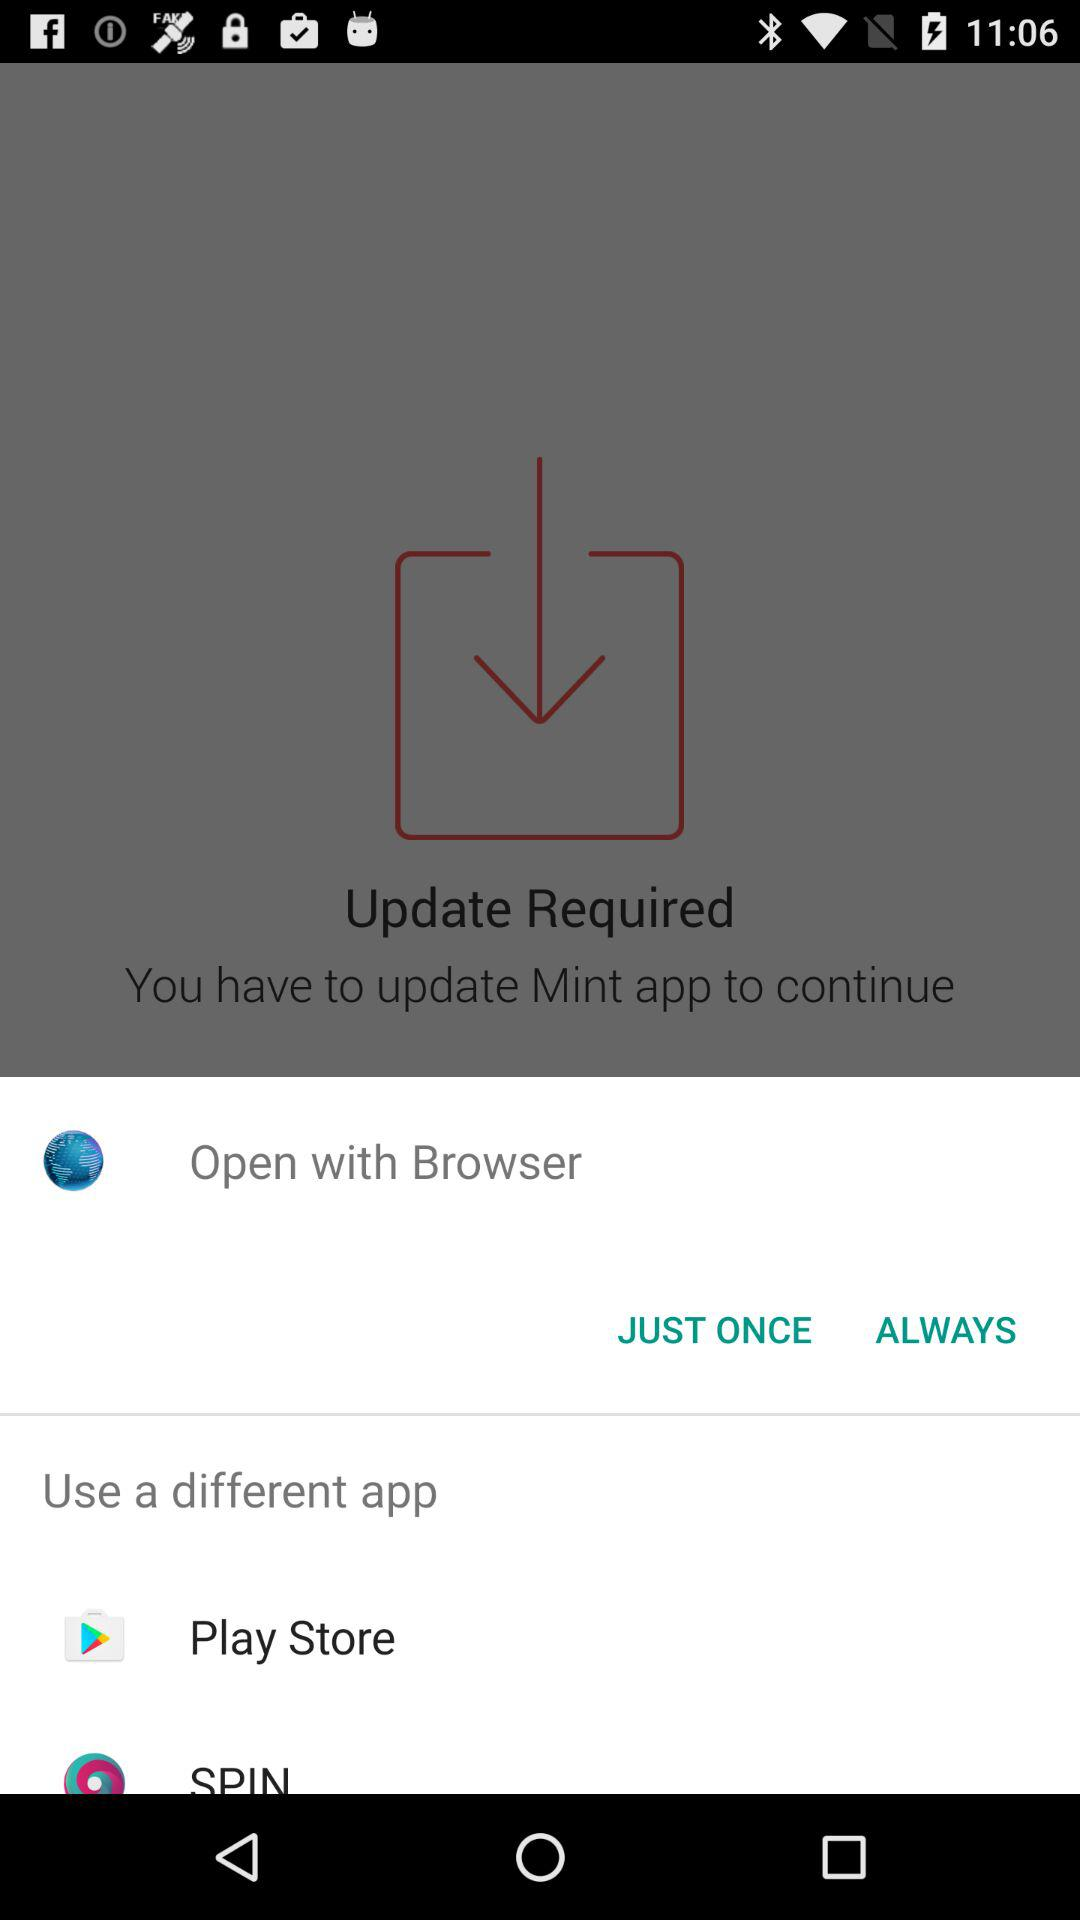What are the different applications that can be used? The applications are "Play Store" and "SPIN". 